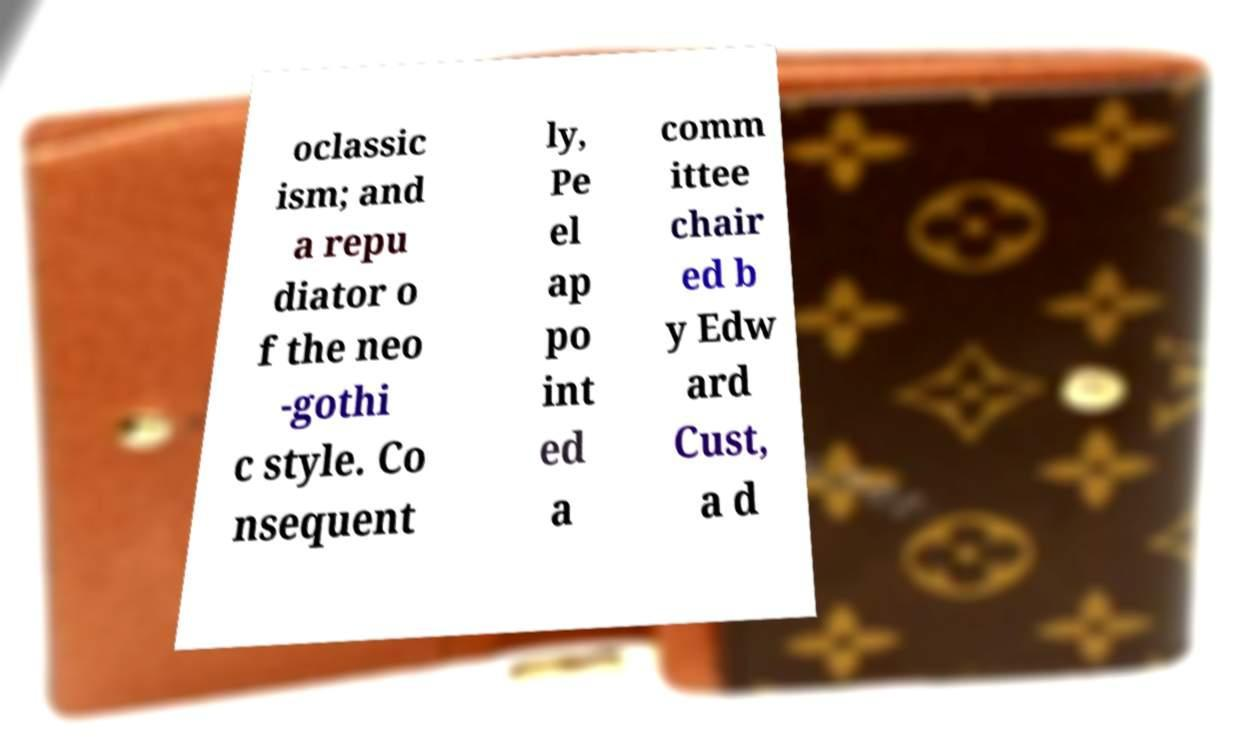Can you accurately transcribe the text from the provided image for me? oclassic ism; and a repu diator o f the neo -gothi c style. Co nsequent ly, Pe el ap po int ed a comm ittee chair ed b y Edw ard Cust, a d 